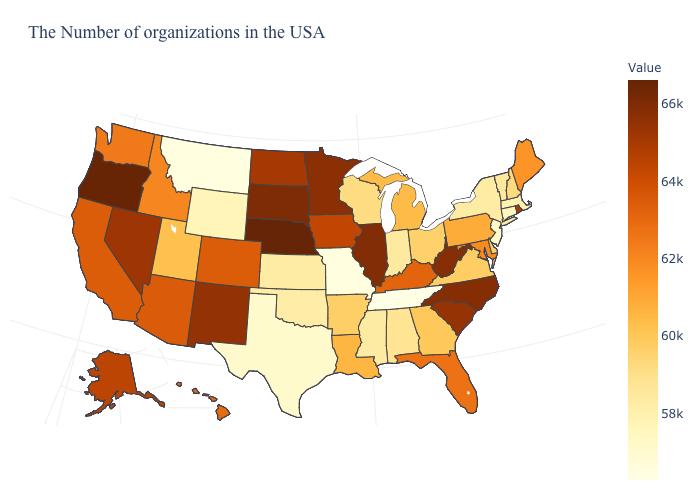Does Alabama have the highest value in the USA?
Write a very short answer. No. Is the legend a continuous bar?
Quick response, please. Yes. Does Nebraska have the highest value in the USA?
Give a very brief answer. Yes. Which states have the lowest value in the South?
Keep it brief. Tennessee. Does the map have missing data?
Concise answer only. No. 